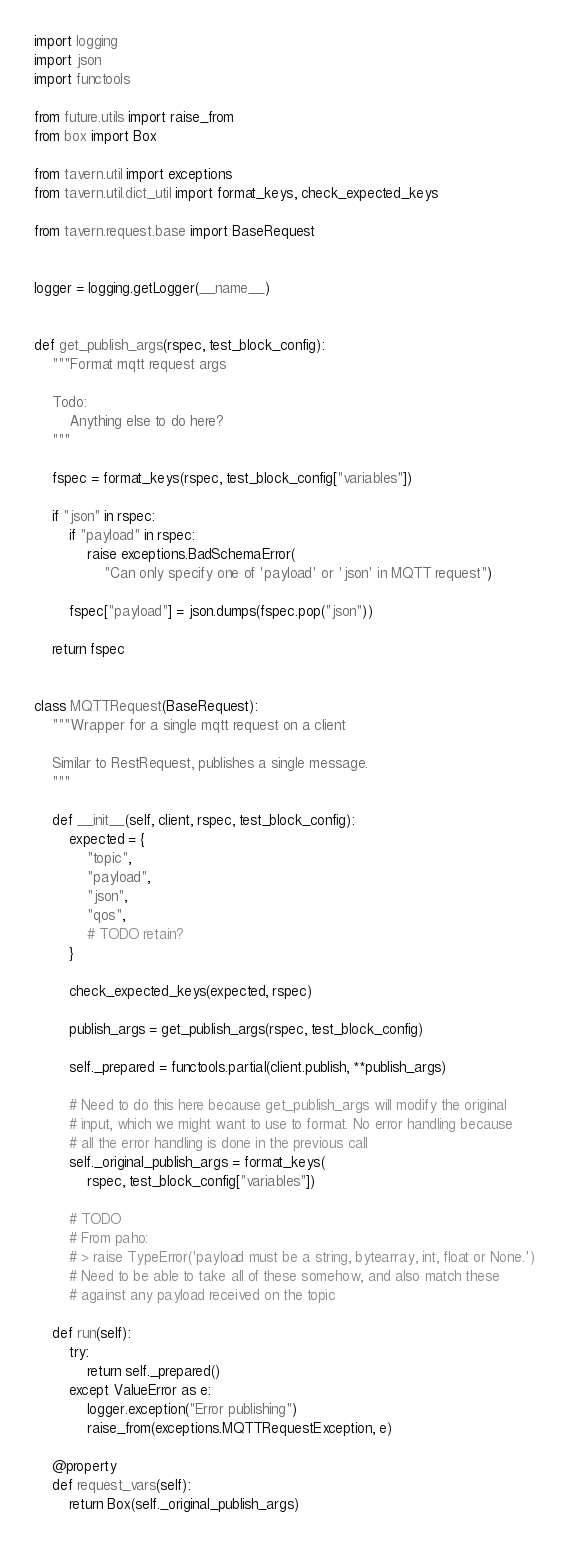<code> <loc_0><loc_0><loc_500><loc_500><_Python_>import logging
import json
import functools

from future.utils import raise_from
from box import Box

from tavern.util import exceptions
from tavern.util.dict_util import format_keys, check_expected_keys

from tavern.request.base import BaseRequest


logger = logging.getLogger(__name__)


def get_publish_args(rspec, test_block_config):
    """Format mqtt request args

    Todo:
        Anything else to do here?
    """

    fspec = format_keys(rspec, test_block_config["variables"])

    if "json" in rspec:
        if "payload" in rspec:
            raise exceptions.BadSchemaError(
                "Can only specify one of 'payload' or 'json' in MQTT request")

        fspec["payload"] = json.dumps(fspec.pop("json"))

    return fspec


class MQTTRequest(BaseRequest):
    """Wrapper for a single mqtt request on a client

    Similar to RestRequest, publishes a single message.
    """

    def __init__(self, client, rspec, test_block_config):
        expected = {
            "topic",
            "payload",
            "json",
            "qos",
            # TODO retain?
        }

        check_expected_keys(expected, rspec)

        publish_args = get_publish_args(rspec, test_block_config)

        self._prepared = functools.partial(client.publish, **publish_args)

        # Need to do this here because get_publish_args will modify the original
        # input, which we might want to use to format. No error handling because
        # all the error handling is done in the previous call
        self._original_publish_args = format_keys(
            rspec, test_block_config["variables"])

        # TODO
        # From paho:
        # > raise TypeError('payload must be a string, bytearray, int, float or None.')
        # Need to be able to take all of these somehow, and also match these
        # against any payload received on the topic

    def run(self):
        try:
            return self._prepared()
        except ValueError as e:
            logger.exception("Error publishing")
            raise_from(exceptions.MQTTRequestException, e)

    @property
    def request_vars(self):
        return Box(self._original_publish_args)
</code> 